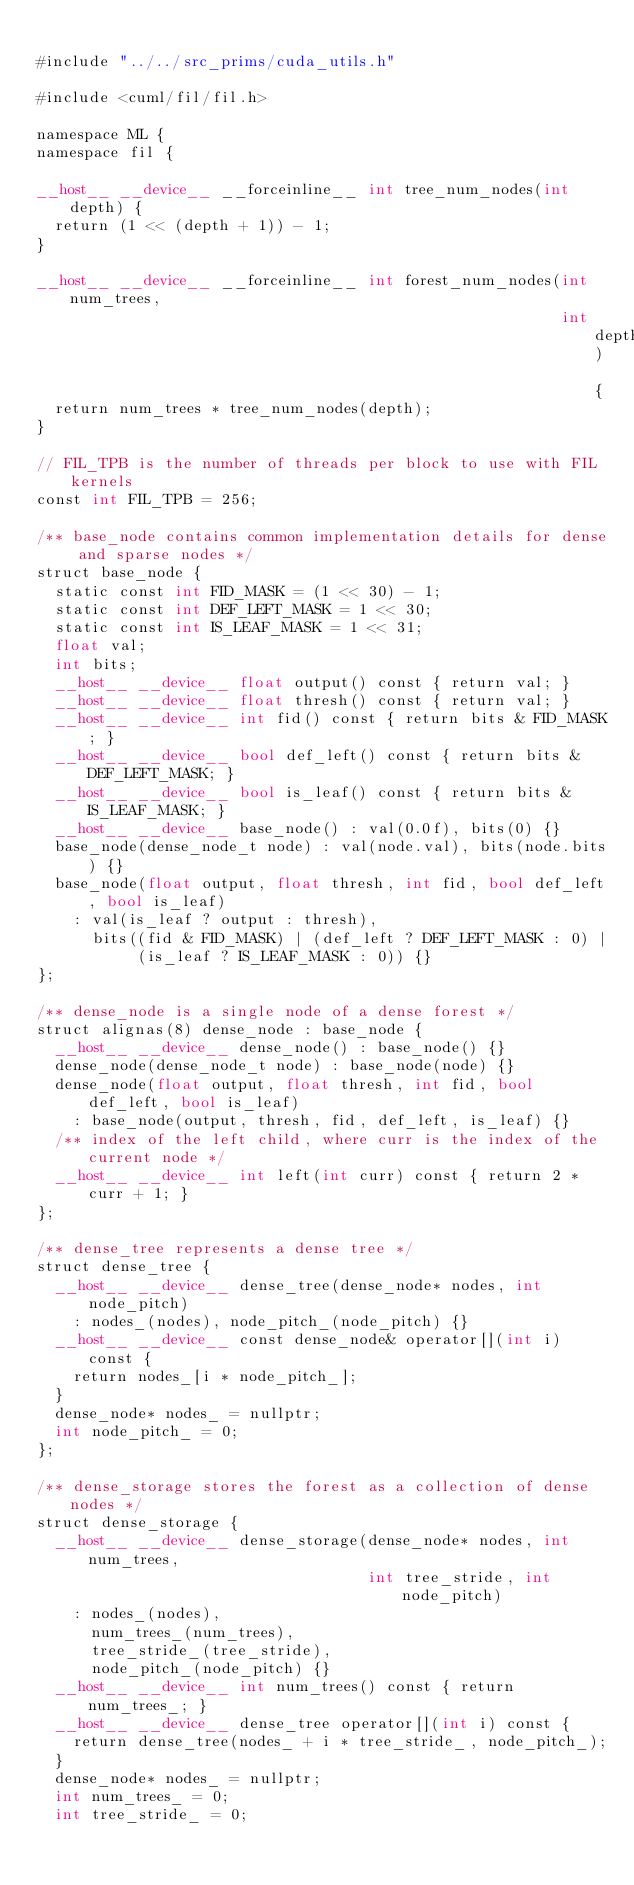<code> <loc_0><loc_0><loc_500><loc_500><_Cuda_>
#include "../../src_prims/cuda_utils.h"

#include <cuml/fil/fil.h>

namespace ML {
namespace fil {

__host__ __device__ __forceinline__ int tree_num_nodes(int depth) {
  return (1 << (depth + 1)) - 1;
}

__host__ __device__ __forceinline__ int forest_num_nodes(int num_trees,
                                                         int depth) {
  return num_trees * tree_num_nodes(depth);
}

// FIL_TPB is the number of threads per block to use with FIL kernels
const int FIL_TPB = 256;

/** base_node contains common implementation details for dense and sparse nodes */
struct base_node {
  static const int FID_MASK = (1 << 30) - 1;
  static const int DEF_LEFT_MASK = 1 << 30;
  static const int IS_LEAF_MASK = 1 << 31;
  float val;
  int bits;
  __host__ __device__ float output() const { return val; }
  __host__ __device__ float thresh() const { return val; }
  __host__ __device__ int fid() const { return bits & FID_MASK; }
  __host__ __device__ bool def_left() const { return bits & DEF_LEFT_MASK; }
  __host__ __device__ bool is_leaf() const { return bits & IS_LEAF_MASK; }
  __host__ __device__ base_node() : val(0.0f), bits(0) {}
  base_node(dense_node_t node) : val(node.val), bits(node.bits) {}
  base_node(float output, float thresh, int fid, bool def_left, bool is_leaf)
    : val(is_leaf ? output : thresh),
      bits((fid & FID_MASK) | (def_left ? DEF_LEFT_MASK : 0) |
           (is_leaf ? IS_LEAF_MASK : 0)) {}
};

/** dense_node is a single node of a dense forest */
struct alignas(8) dense_node : base_node {
  __host__ __device__ dense_node() : base_node() {}
  dense_node(dense_node_t node) : base_node(node) {}
  dense_node(float output, float thresh, int fid, bool def_left, bool is_leaf)
    : base_node(output, thresh, fid, def_left, is_leaf) {}
  /** index of the left child, where curr is the index of the current node */
  __host__ __device__ int left(int curr) const { return 2 * curr + 1; }
};

/** dense_tree represents a dense tree */
struct dense_tree {
  __host__ __device__ dense_tree(dense_node* nodes, int node_pitch)
    : nodes_(nodes), node_pitch_(node_pitch) {}
  __host__ __device__ const dense_node& operator[](int i) const {
    return nodes_[i * node_pitch_];
  }
  dense_node* nodes_ = nullptr;
  int node_pitch_ = 0;
};

/** dense_storage stores the forest as a collection of dense nodes */
struct dense_storage {
  __host__ __device__ dense_storage(dense_node* nodes, int num_trees,
                                    int tree_stride, int node_pitch)
    : nodes_(nodes),
      num_trees_(num_trees),
      tree_stride_(tree_stride),
      node_pitch_(node_pitch) {}
  __host__ __device__ int num_trees() const { return num_trees_; }
  __host__ __device__ dense_tree operator[](int i) const {
    return dense_tree(nodes_ + i * tree_stride_, node_pitch_);
  }
  dense_node* nodes_ = nullptr;
  int num_trees_ = 0;
  int tree_stride_ = 0;</code> 